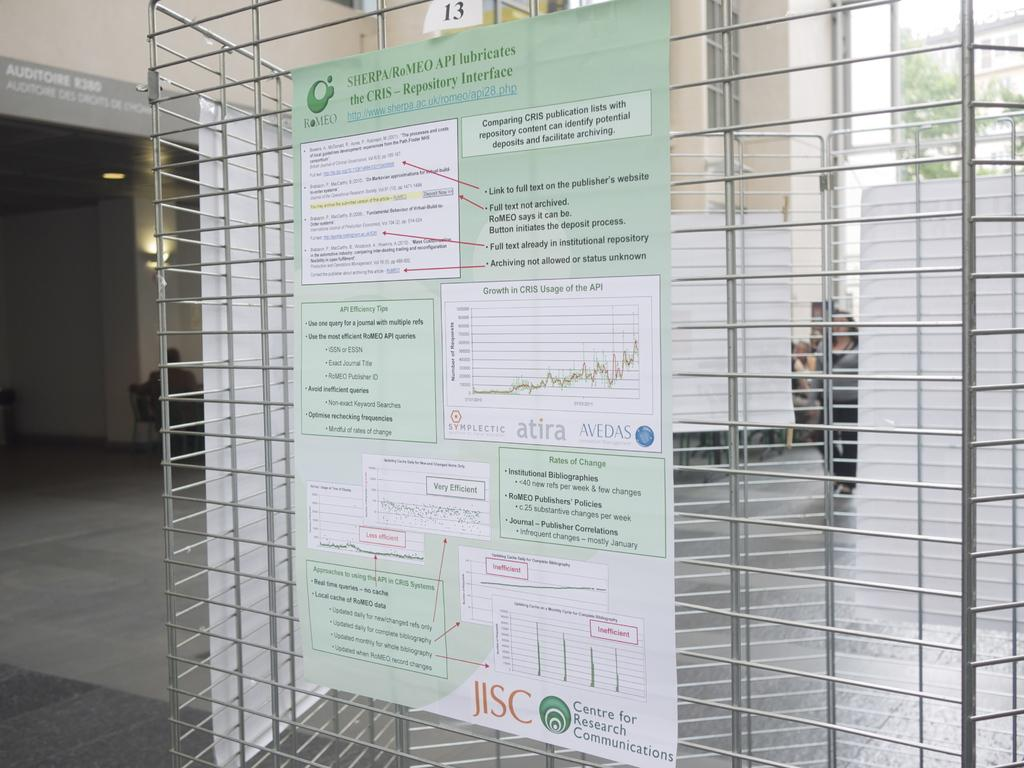Provide a one-sentence caption for the provided image. Sign hanging on a fence that says Repository Interface. 